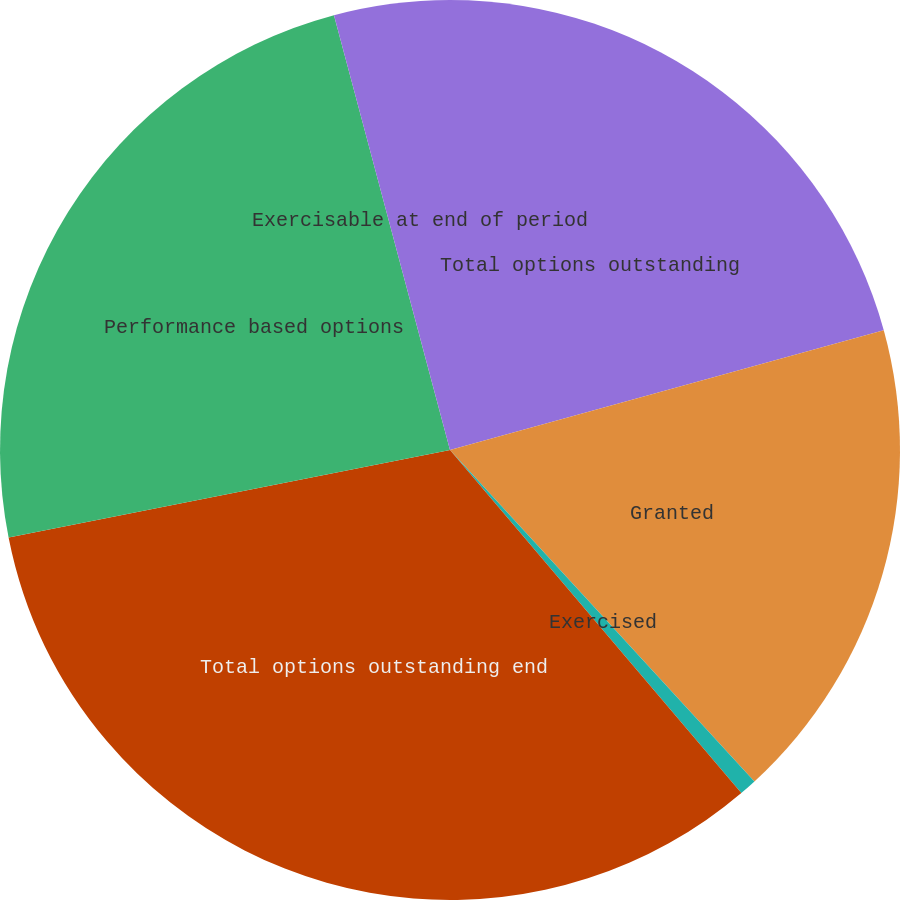Convert chart to OTSL. <chart><loc_0><loc_0><loc_500><loc_500><pie_chart><fcel>Total options outstanding<fcel>Granted<fcel>Exercised<fcel>Total options outstanding end<fcel>Performance based options<fcel>Exercisable at end of period<nl><fcel>20.71%<fcel>17.46%<fcel>0.62%<fcel>33.09%<fcel>23.96%<fcel>4.15%<nl></chart> 